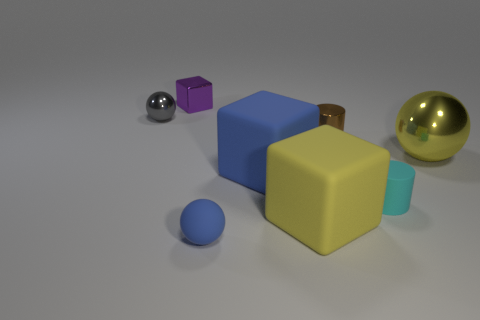Add 1 big brown spheres. How many objects exist? 9 Subtract all balls. How many objects are left? 5 Add 6 small shiny cylinders. How many small shiny cylinders exist? 7 Subtract 0 gray cylinders. How many objects are left? 8 Subtract all yellow cubes. Subtract all yellow rubber cubes. How many objects are left? 6 Add 5 small rubber objects. How many small rubber objects are left? 7 